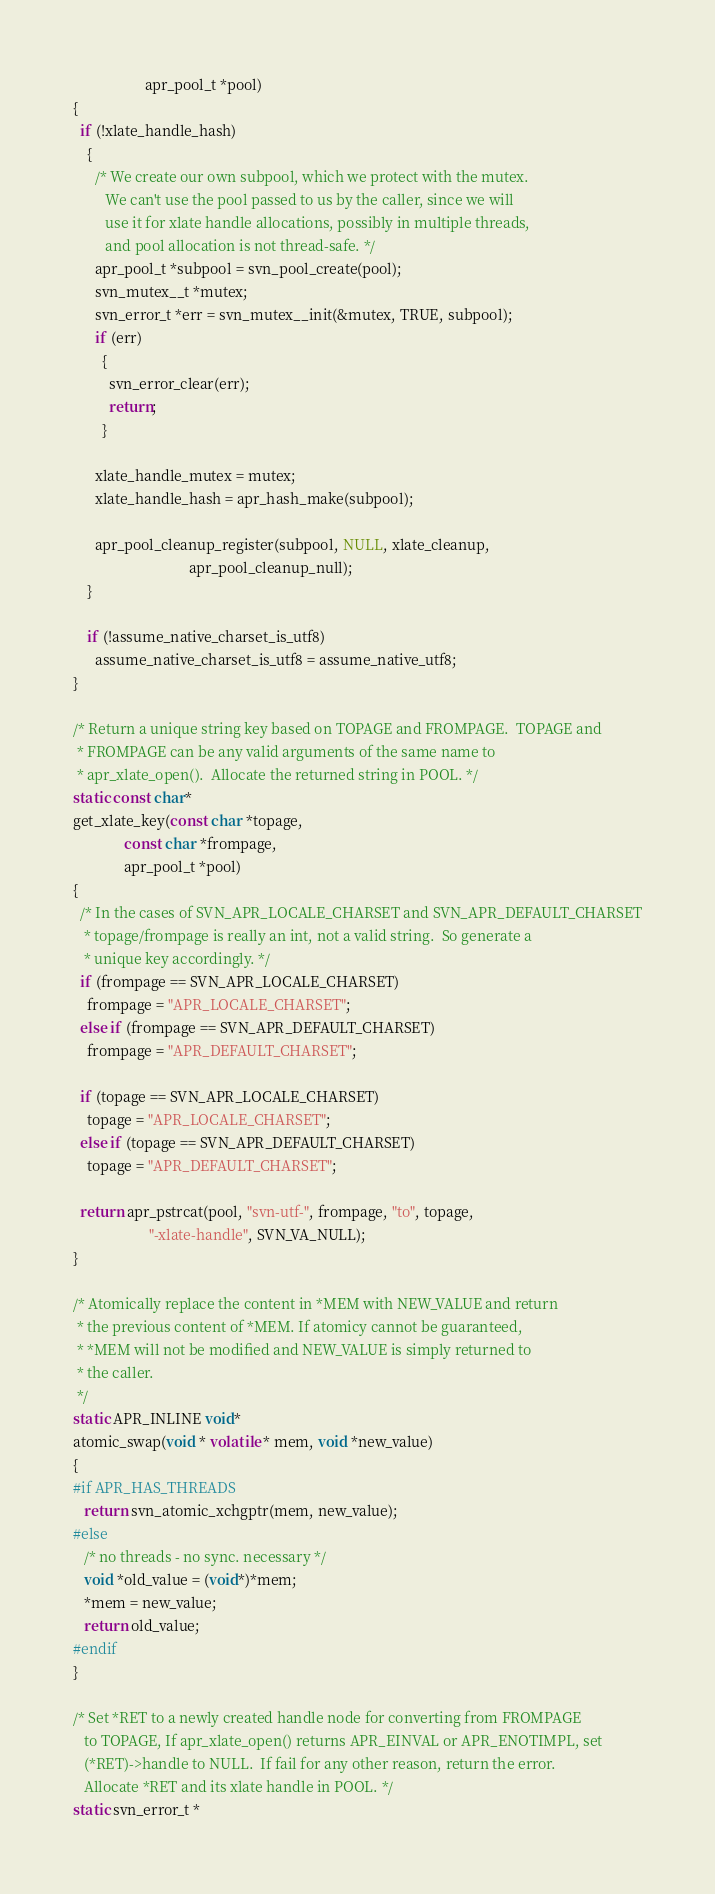<code> <loc_0><loc_0><loc_500><loc_500><_C_>                    apr_pool_t *pool)
{
  if (!xlate_handle_hash)
    {
      /* We create our own subpool, which we protect with the mutex.
         We can't use the pool passed to us by the caller, since we will
         use it for xlate handle allocations, possibly in multiple threads,
         and pool allocation is not thread-safe. */
      apr_pool_t *subpool = svn_pool_create(pool);
      svn_mutex__t *mutex;
      svn_error_t *err = svn_mutex__init(&mutex, TRUE, subpool);
      if (err)
        {
          svn_error_clear(err);
          return;
        }

      xlate_handle_mutex = mutex;
      xlate_handle_hash = apr_hash_make(subpool);

      apr_pool_cleanup_register(subpool, NULL, xlate_cleanup,
                                apr_pool_cleanup_null);
    }

    if (!assume_native_charset_is_utf8)
      assume_native_charset_is_utf8 = assume_native_utf8;
}

/* Return a unique string key based on TOPAGE and FROMPAGE.  TOPAGE and
 * FROMPAGE can be any valid arguments of the same name to
 * apr_xlate_open().  Allocate the returned string in POOL. */
static const char*
get_xlate_key(const char *topage,
              const char *frompage,
              apr_pool_t *pool)
{
  /* In the cases of SVN_APR_LOCALE_CHARSET and SVN_APR_DEFAULT_CHARSET
   * topage/frompage is really an int, not a valid string.  So generate a
   * unique key accordingly. */
  if (frompage == SVN_APR_LOCALE_CHARSET)
    frompage = "APR_LOCALE_CHARSET";
  else if (frompage == SVN_APR_DEFAULT_CHARSET)
    frompage = "APR_DEFAULT_CHARSET";

  if (topage == SVN_APR_LOCALE_CHARSET)
    topage = "APR_LOCALE_CHARSET";
  else if (topage == SVN_APR_DEFAULT_CHARSET)
    topage = "APR_DEFAULT_CHARSET";

  return apr_pstrcat(pool, "svn-utf-", frompage, "to", topage,
                     "-xlate-handle", SVN_VA_NULL);
}

/* Atomically replace the content in *MEM with NEW_VALUE and return
 * the previous content of *MEM. If atomicy cannot be guaranteed,
 * *MEM will not be modified and NEW_VALUE is simply returned to
 * the caller.
 */
static APR_INLINE void*
atomic_swap(void * volatile * mem, void *new_value)
{
#if APR_HAS_THREADS
   return svn_atomic_xchgptr(mem, new_value);
#else
   /* no threads - no sync. necessary */
   void *old_value = (void*)*mem;
   *mem = new_value;
   return old_value;
#endif
}

/* Set *RET to a newly created handle node for converting from FROMPAGE
   to TOPAGE, If apr_xlate_open() returns APR_EINVAL or APR_ENOTIMPL, set
   (*RET)->handle to NULL.  If fail for any other reason, return the error.
   Allocate *RET and its xlate handle in POOL. */
static svn_error_t *</code> 